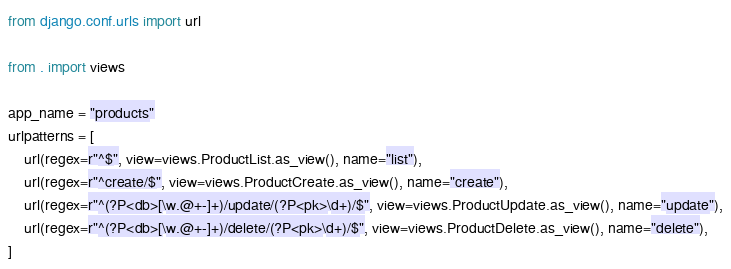<code> <loc_0><loc_0><loc_500><loc_500><_Python_>from django.conf.urls import url

from . import views

app_name = "products"
urlpatterns = [
    url(regex=r"^$", view=views.ProductList.as_view(), name="list"),
    url(regex=r"^create/$", view=views.ProductCreate.as_view(), name="create"),
    url(regex=r"^(?P<db>[\w.@+-]+)/update/(?P<pk>\d+)/$", view=views.ProductUpdate.as_view(), name="update"),
    url(regex=r"^(?P<db>[\w.@+-]+)/delete/(?P<pk>\d+)/$", view=views.ProductDelete.as_view(), name="delete"),
]
</code> 